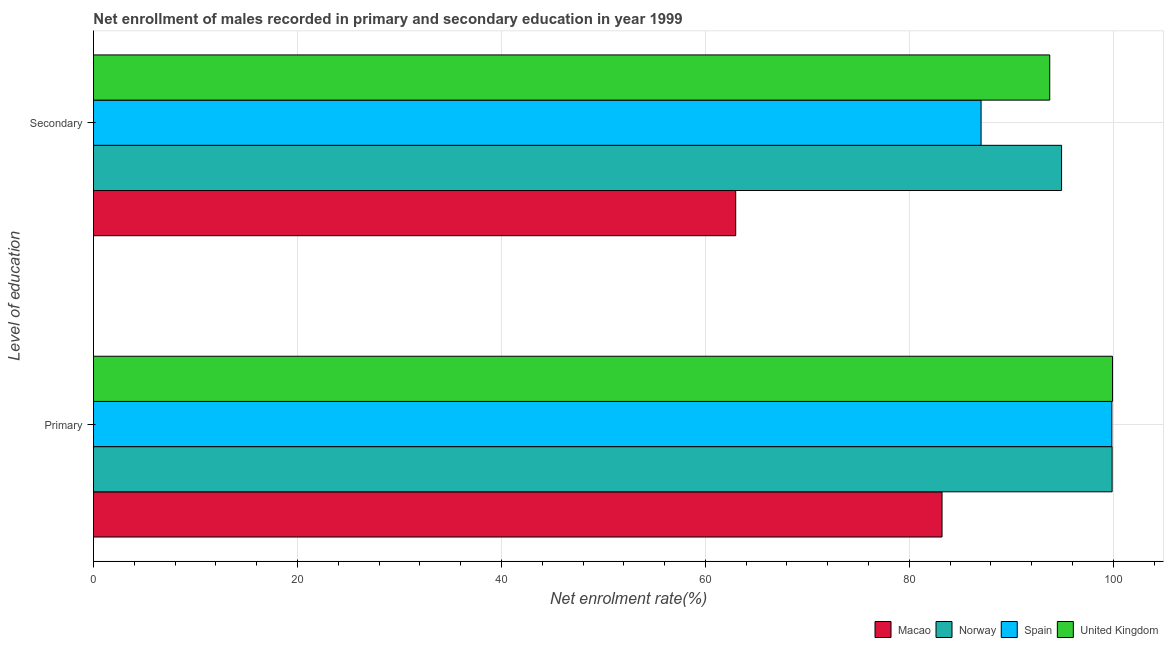What is the label of the 2nd group of bars from the top?
Offer a very short reply. Primary. What is the enrollment rate in secondary education in United Kingdom?
Provide a succinct answer. 93.76. Across all countries, what is the maximum enrollment rate in primary education?
Your response must be concise. 99.92. Across all countries, what is the minimum enrollment rate in primary education?
Provide a short and direct response. 83.2. In which country was the enrollment rate in secondary education minimum?
Your answer should be compact. Macao. What is the total enrollment rate in primary education in the graph?
Keep it short and to the point. 382.86. What is the difference between the enrollment rate in secondary education in Norway and that in United Kingdom?
Your answer should be very brief. 1.16. What is the difference between the enrollment rate in secondary education in Spain and the enrollment rate in primary education in United Kingdom?
Provide a short and direct response. -12.89. What is the average enrollment rate in secondary education per country?
Your response must be concise. 84.67. What is the difference between the enrollment rate in secondary education and enrollment rate in primary education in United Kingdom?
Ensure brevity in your answer.  -6.16. What is the ratio of the enrollment rate in secondary education in Norway to that in Macao?
Your response must be concise. 1.51. Is the enrollment rate in secondary education in Spain less than that in United Kingdom?
Your response must be concise. Yes. What does the 3rd bar from the top in Secondary represents?
Make the answer very short. Norway. How many bars are there?
Offer a terse response. 8. What is the difference between two consecutive major ticks on the X-axis?
Provide a succinct answer. 20. Are the values on the major ticks of X-axis written in scientific E-notation?
Offer a terse response. No. Does the graph contain grids?
Your response must be concise. Yes. How many legend labels are there?
Your response must be concise. 4. How are the legend labels stacked?
Keep it short and to the point. Horizontal. What is the title of the graph?
Your response must be concise. Net enrollment of males recorded in primary and secondary education in year 1999. Does "Bhutan" appear as one of the legend labels in the graph?
Your answer should be compact. No. What is the label or title of the X-axis?
Offer a terse response. Net enrolment rate(%). What is the label or title of the Y-axis?
Ensure brevity in your answer.  Level of education. What is the Net enrolment rate(%) in Macao in Primary?
Give a very brief answer. 83.2. What is the Net enrolment rate(%) in Norway in Primary?
Provide a succinct answer. 99.88. What is the Net enrolment rate(%) in Spain in Primary?
Your answer should be very brief. 99.86. What is the Net enrolment rate(%) of United Kingdom in Primary?
Your response must be concise. 99.92. What is the Net enrolment rate(%) in Macao in Secondary?
Provide a succinct answer. 62.97. What is the Net enrolment rate(%) of Norway in Secondary?
Ensure brevity in your answer.  94.92. What is the Net enrolment rate(%) in Spain in Secondary?
Keep it short and to the point. 87.03. What is the Net enrolment rate(%) in United Kingdom in Secondary?
Your response must be concise. 93.76. Across all Level of education, what is the maximum Net enrolment rate(%) in Macao?
Your response must be concise. 83.2. Across all Level of education, what is the maximum Net enrolment rate(%) of Norway?
Provide a short and direct response. 99.88. Across all Level of education, what is the maximum Net enrolment rate(%) in Spain?
Keep it short and to the point. 99.86. Across all Level of education, what is the maximum Net enrolment rate(%) of United Kingdom?
Ensure brevity in your answer.  99.92. Across all Level of education, what is the minimum Net enrolment rate(%) of Macao?
Offer a very short reply. 62.97. Across all Level of education, what is the minimum Net enrolment rate(%) of Norway?
Offer a terse response. 94.92. Across all Level of education, what is the minimum Net enrolment rate(%) of Spain?
Offer a terse response. 87.03. Across all Level of education, what is the minimum Net enrolment rate(%) of United Kingdom?
Provide a short and direct response. 93.76. What is the total Net enrolment rate(%) in Macao in the graph?
Provide a succinct answer. 146.18. What is the total Net enrolment rate(%) of Norway in the graph?
Your answer should be very brief. 194.8. What is the total Net enrolment rate(%) of Spain in the graph?
Your answer should be very brief. 186.88. What is the total Net enrolment rate(%) of United Kingdom in the graph?
Your answer should be very brief. 193.68. What is the difference between the Net enrolment rate(%) in Macao in Primary and that in Secondary?
Make the answer very short. 20.23. What is the difference between the Net enrolment rate(%) of Norway in Primary and that in Secondary?
Your answer should be very brief. 4.96. What is the difference between the Net enrolment rate(%) of Spain in Primary and that in Secondary?
Give a very brief answer. 12.83. What is the difference between the Net enrolment rate(%) in United Kingdom in Primary and that in Secondary?
Ensure brevity in your answer.  6.16. What is the difference between the Net enrolment rate(%) of Macao in Primary and the Net enrolment rate(%) of Norway in Secondary?
Your answer should be very brief. -11.72. What is the difference between the Net enrolment rate(%) in Macao in Primary and the Net enrolment rate(%) in Spain in Secondary?
Your response must be concise. -3.83. What is the difference between the Net enrolment rate(%) of Macao in Primary and the Net enrolment rate(%) of United Kingdom in Secondary?
Give a very brief answer. -10.56. What is the difference between the Net enrolment rate(%) in Norway in Primary and the Net enrolment rate(%) in Spain in Secondary?
Give a very brief answer. 12.85. What is the difference between the Net enrolment rate(%) of Norway in Primary and the Net enrolment rate(%) of United Kingdom in Secondary?
Your response must be concise. 6.12. What is the difference between the Net enrolment rate(%) in Spain in Primary and the Net enrolment rate(%) in United Kingdom in Secondary?
Provide a succinct answer. 6.09. What is the average Net enrolment rate(%) of Macao per Level of education?
Offer a terse response. 73.09. What is the average Net enrolment rate(%) in Norway per Level of education?
Provide a short and direct response. 97.4. What is the average Net enrolment rate(%) in Spain per Level of education?
Offer a terse response. 93.44. What is the average Net enrolment rate(%) of United Kingdom per Level of education?
Provide a succinct answer. 96.84. What is the difference between the Net enrolment rate(%) in Macao and Net enrolment rate(%) in Norway in Primary?
Offer a very short reply. -16.68. What is the difference between the Net enrolment rate(%) of Macao and Net enrolment rate(%) of Spain in Primary?
Your answer should be very brief. -16.65. What is the difference between the Net enrolment rate(%) of Macao and Net enrolment rate(%) of United Kingdom in Primary?
Keep it short and to the point. -16.72. What is the difference between the Net enrolment rate(%) in Norway and Net enrolment rate(%) in Spain in Primary?
Ensure brevity in your answer.  0.03. What is the difference between the Net enrolment rate(%) in Norway and Net enrolment rate(%) in United Kingdom in Primary?
Your response must be concise. -0.04. What is the difference between the Net enrolment rate(%) in Spain and Net enrolment rate(%) in United Kingdom in Primary?
Provide a short and direct response. -0.07. What is the difference between the Net enrolment rate(%) in Macao and Net enrolment rate(%) in Norway in Secondary?
Give a very brief answer. -31.95. What is the difference between the Net enrolment rate(%) in Macao and Net enrolment rate(%) in Spain in Secondary?
Your answer should be compact. -24.06. What is the difference between the Net enrolment rate(%) of Macao and Net enrolment rate(%) of United Kingdom in Secondary?
Ensure brevity in your answer.  -30.79. What is the difference between the Net enrolment rate(%) in Norway and Net enrolment rate(%) in Spain in Secondary?
Offer a very short reply. 7.89. What is the difference between the Net enrolment rate(%) in Norway and Net enrolment rate(%) in United Kingdom in Secondary?
Make the answer very short. 1.16. What is the difference between the Net enrolment rate(%) of Spain and Net enrolment rate(%) of United Kingdom in Secondary?
Make the answer very short. -6.73. What is the ratio of the Net enrolment rate(%) of Macao in Primary to that in Secondary?
Give a very brief answer. 1.32. What is the ratio of the Net enrolment rate(%) of Norway in Primary to that in Secondary?
Make the answer very short. 1.05. What is the ratio of the Net enrolment rate(%) of Spain in Primary to that in Secondary?
Keep it short and to the point. 1.15. What is the ratio of the Net enrolment rate(%) in United Kingdom in Primary to that in Secondary?
Your response must be concise. 1.07. What is the difference between the highest and the second highest Net enrolment rate(%) in Macao?
Provide a short and direct response. 20.23. What is the difference between the highest and the second highest Net enrolment rate(%) in Norway?
Your response must be concise. 4.96. What is the difference between the highest and the second highest Net enrolment rate(%) of Spain?
Keep it short and to the point. 12.83. What is the difference between the highest and the second highest Net enrolment rate(%) in United Kingdom?
Keep it short and to the point. 6.16. What is the difference between the highest and the lowest Net enrolment rate(%) in Macao?
Offer a very short reply. 20.23. What is the difference between the highest and the lowest Net enrolment rate(%) of Norway?
Your response must be concise. 4.96. What is the difference between the highest and the lowest Net enrolment rate(%) of Spain?
Offer a terse response. 12.83. What is the difference between the highest and the lowest Net enrolment rate(%) of United Kingdom?
Offer a very short reply. 6.16. 